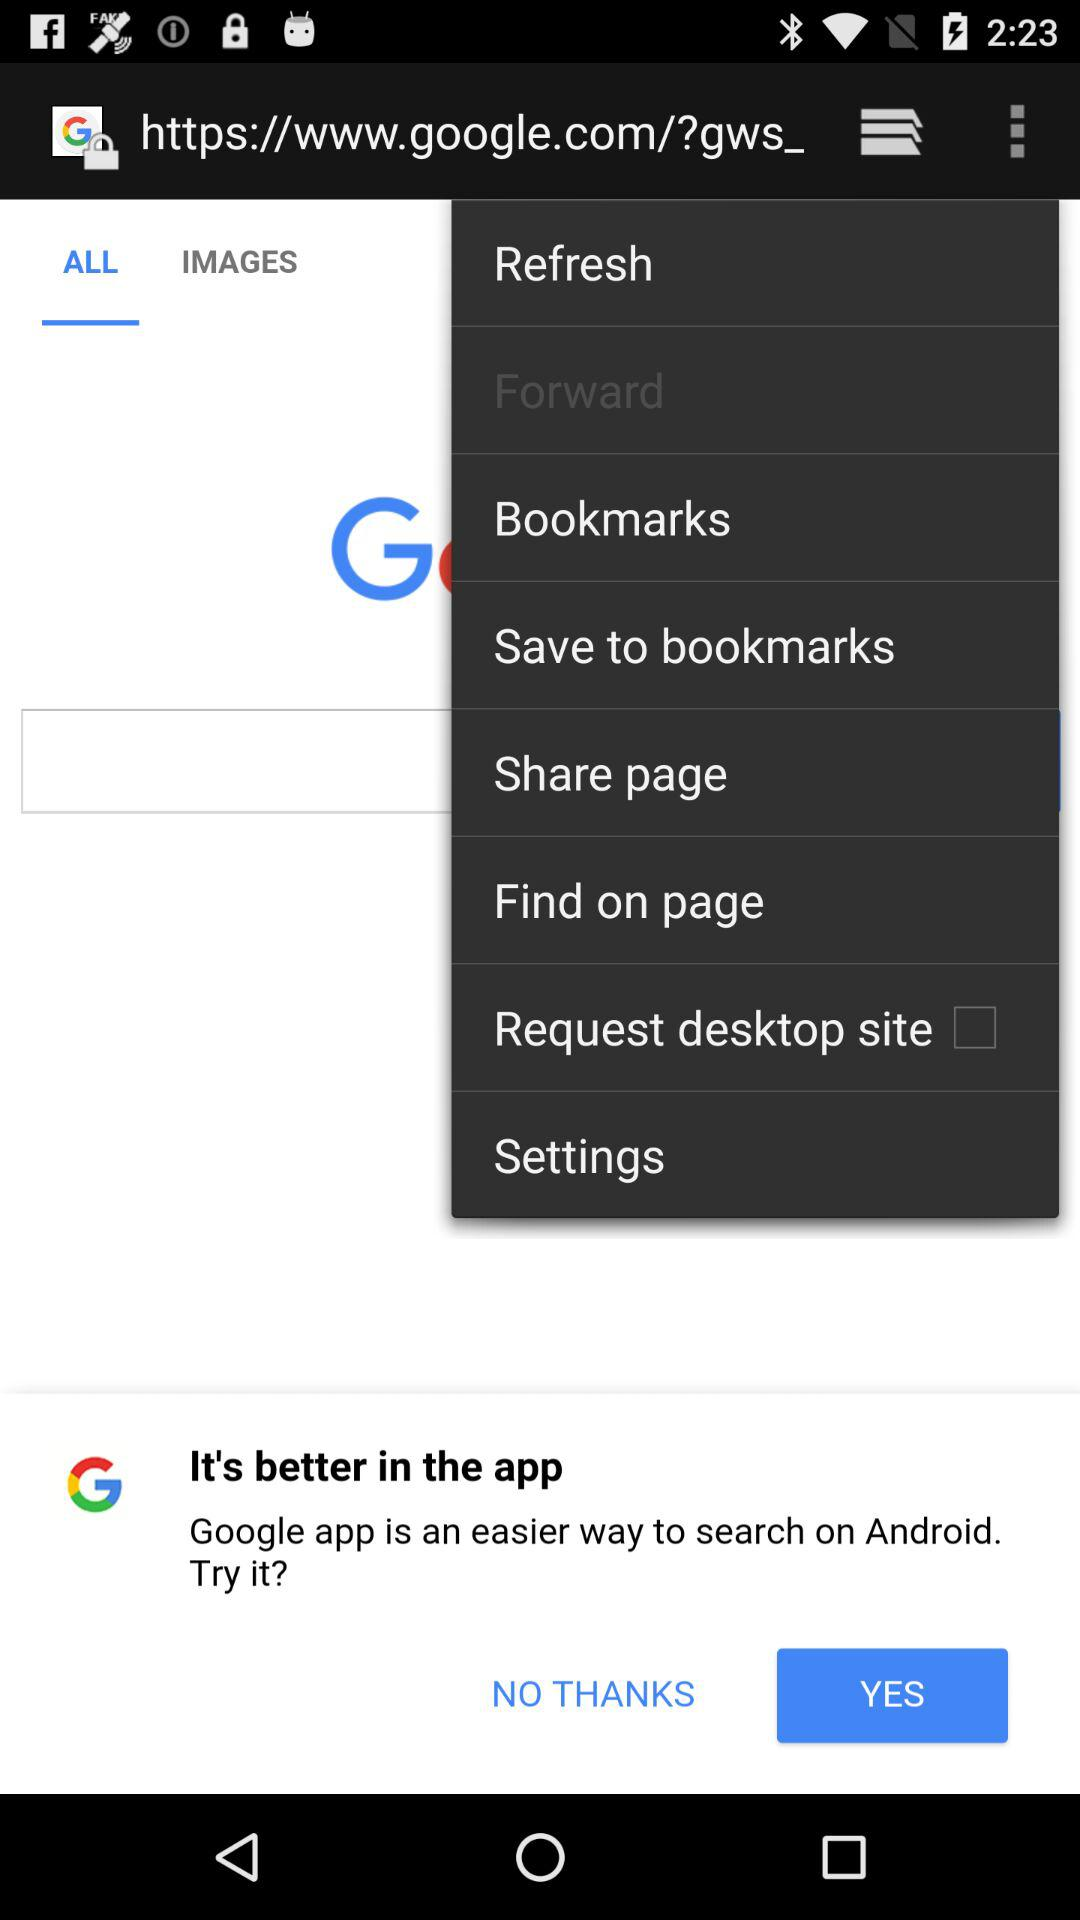What is the status of "Request desktop site"? The status of "Request desktop site" is "off". 